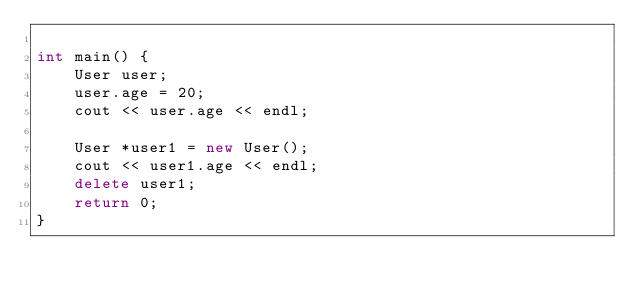<code> <loc_0><loc_0><loc_500><loc_500><_C++_>
int main() {
	User user;
	user.age = 20;
	cout << user.age << endl;

	User *user1 = new User();
	cout << user1.age << endl;
	delete user1; 
	return 0;
}
</code> 